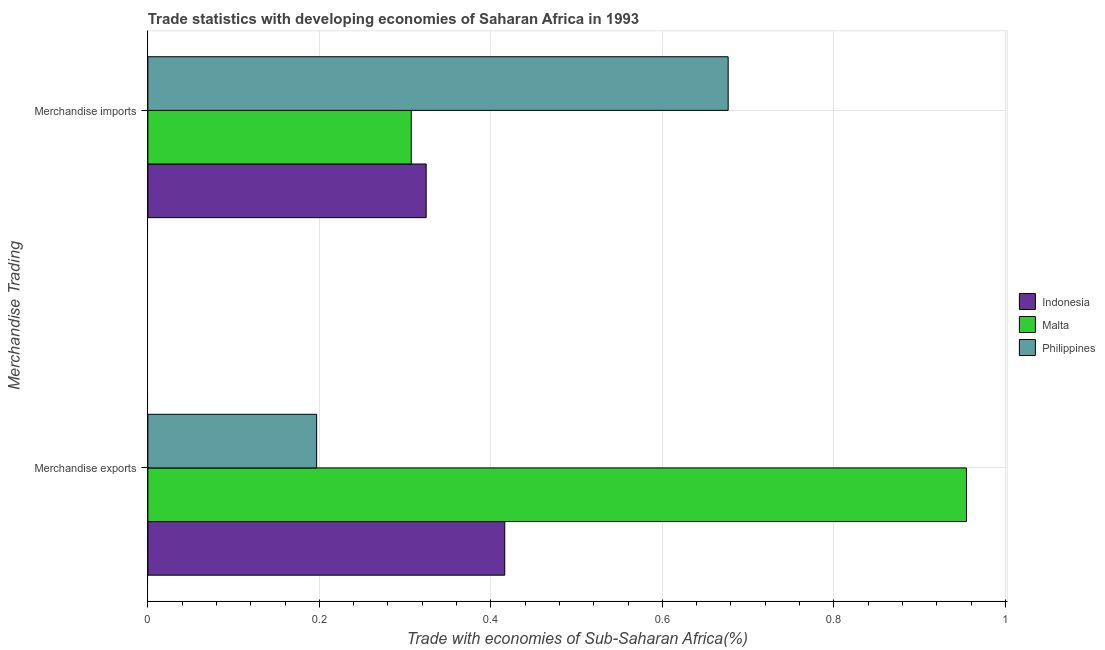How many different coloured bars are there?
Your answer should be compact. 3. How many bars are there on the 2nd tick from the bottom?
Keep it short and to the point. 3. What is the merchandise exports in Indonesia?
Make the answer very short. 0.42. Across all countries, what is the maximum merchandise imports?
Offer a very short reply. 0.68. Across all countries, what is the minimum merchandise exports?
Provide a short and direct response. 0.2. What is the total merchandise imports in the graph?
Keep it short and to the point. 1.31. What is the difference between the merchandise exports in Indonesia and that in Malta?
Provide a succinct answer. -0.54. What is the difference between the merchandise exports in Philippines and the merchandise imports in Malta?
Give a very brief answer. -0.11. What is the average merchandise imports per country?
Offer a terse response. 0.44. What is the difference between the merchandise exports and merchandise imports in Philippines?
Your answer should be compact. -0.48. In how many countries, is the merchandise imports greater than 0.04 %?
Ensure brevity in your answer.  3. What is the ratio of the merchandise imports in Philippines to that in Malta?
Your response must be concise. 2.2. Is the merchandise exports in Indonesia less than that in Philippines?
Give a very brief answer. No. In how many countries, is the merchandise exports greater than the average merchandise exports taken over all countries?
Ensure brevity in your answer.  1. How many bars are there?
Provide a succinct answer. 6. What is the difference between two consecutive major ticks on the X-axis?
Offer a very short reply. 0.2. Does the graph contain any zero values?
Keep it short and to the point. No. Does the graph contain grids?
Your response must be concise. Yes. Where does the legend appear in the graph?
Your response must be concise. Center right. How many legend labels are there?
Your answer should be compact. 3. How are the legend labels stacked?
Offer a very short reply. Vertical. What is the title of the graph?
Your response must be concise. Trade statistics with developing economies of Saharan Africa in 1993. Does "Liberia" appear as one of the legend labels in the graph?
Keep it short and to the point. No. What is the label or title of the X-axis?
Offer a terse response. Trade with economies of Sub-Saharan Africa(%). What is the label or title of the Y-axis?
Make the answer very short. Merchandise Trading. What is the Trade with economies of Sub-Saharan Africa(%) of Indonesia in Merchandise exports?
Your answer should be very brief. 0.42. What is the Trade with economies of Sub-Saharan Africa(%) of Malta in Merchandise exports?
Your response must be concise. 0.95. What is the Trade with economies of Sub-Saharan Africa(%) of Philippines in Merchandise exports?
Your answer should be compact. 0.2. What is the Trade with economies of Sub-Saharan Africa(%) in Indonesia in Merchandise imports?
Provide a succinct answer. 0.32. What is the Trade with economies of Sub-Saharan Africa(%) in Malta in Merchandise imports?
Offer a very short reply. 0.31. What is the Trade with economies of Sub-Saharan Africa(%) in Philippines in Merchandise imports?
Provide a succinct answer. 0.68. Across all Merchandise Trading, what is the maximum Trade with economies of Sub-Saharan Africa(%) in Indonesia?
Your answer should be very brief. 0.42. Across all Merchandise Trading, what is the maximum Trade with economies of Sub-Saharan Africa(%) in Malta?
Give a very brief answer. 0.95. Across all Merchandise Trading, what is the maximum Trade with economies of Sub-Saharan Africa(%) in Philippines?
Keep it short and to the point. 0.68. Across all Merchandise Trading, what is the minimum Trade with economies of Sub-Saharan Africa(%) of Indonesia?
Offer a very short reply. 0.32. Across all Merchandise Trading, what is the minimum Trade with economies of Sub-Saharan Africa(%) of Malta?
Ensure brevity in your answer.  0.31. Across all Merchandise Trading, what is the minimum Trade with economies of Sub-Saharan Africa(%) of Philippines?
Your answer should be very brief. 0.2. What is the total Trade with economies of Sub-Saharan Africa(%) in Indonesia in the graph?
Your answer should be very brief. 0.74. What is the total Trade with economies of Sub-Saharan Africa(%) in Malta in the graph?
Keep it short and to the point. 1.26. What is the total Trade with economies of Sub-Saharan Africa(%) of Philippines in the graph?
Ensure brevity in your answer.  0.87. What is the difference between the Trade with economies of Sub-Saharan Africa(%) of Indonesia in Merchandise exports and that in Merchandise imports?
Provide a short and direct response. 0.09. What is the difference between the Trade with economies of Sub-Saharan Africa(%) in Malta in Merchandise exports and that in Merchandise imports?
Provide a succinct answer. 0.65. What is the difference between the Trade with economies of Sub-Saharan Africa(%) of Philippines in Merchandise exports and that in Merchandise imports?
Give a very brief answer. -0.48. What is the difference between the Trade with economies of Sub-Saharan Africa(%) in Indonesia in Merchandise exports and the Trade with economies of Sub-Saharan Africa(%) in Malta in Merchandise imports?
Provide a succinct answer. 0.11. What is the difference between the Trade with economies of Sub-Saharan Africa(%) of Indonesia in Merchandise exports and the Trade with economies of Sub-Saharan Africa(%) of Philippines in Merchandise imports?
Your answer should be very brief. -0.26. What is the difference between the Trade with economies of Sub-Saharan Africa(%) of Malta in Merchandise exports and the Trade with economies of Sub-Saharan Africa(%) of Philippines in Merchandise imports?
Your response must be concise. 0.28. What is the average Trade with economies of Sub-Saharan Africa(%) in Indonesia per Merchandise Trading?
Provide a short and direct response. 0.37. What is the average Trade with economies of Sub-Saharan Africa(%) of Malta per Merchandise Trading?
Provide a succinct answer. 0.63. What is the average Trade with economies of Sub-Saharan Africa(%) of Philippines per Merchandise Trading?
Offer a very short reply. 0.44. What is the difference between the Trade with economies of Sub-Saharan Africa(%) of Indonesia and Trade with economies of Sub-Saharan Africa(%) of Malta in Merchandise exports?
Your answer should be compact. -0.54. What is the difference between the Trade with economies of Sub-Saharan Africa(%) of Indonesia and Trade with economies of Sub-Saharan Africa(%) of Philippines in Merchandise exports?
Offer a very short reply. 0.22. What is the difference between the Trade with economies of Sub-Saharan Africa(%) in Malta and Trade with economies of Sub-Saharan Africa(%) in Philippines in Merchandise exports?
Provide a short and direct response. 0.76. What is the difference between the Trade with economies of Sub-Saharan Africa(%) of Indonesia and Trade with economies of Sub-Saharan Africa(%) of Malta in Merchandise imports?
Your answer should be compact. 0.02. What is the difference between the Trade with economies of Sub-Saharan Africa(%) of Indonesia and Trade with economies of Sub-Saharan Africa(%) of Philippines in Merchandise imports?
Ensure brevity in your answer.  -0.35. What is the difference between the Trade with economies of Sub-Saharan Africa(%) of Malta and Trade with economies of Sub-Saharan Africa(%) of Philippines in Merchandise imports?
Keep it short and to the point. -0.37. What is the ratio of the Trade with economies of Sub-Saharan Africa(%) in Indonesia in Merchandise exports to that in Merchandise imports?
Make the answer very short. 1.28. What is the ratio of the Trade with economies of Sub-Saharan Africa(%) of Malta in Merchandise exports to that in Merchandise imports?
Give a very brief answer. 3.11. What is the ratio of the Trade with economies of Sub-Saharan Africa(%) of Philippines in Merchandise exports to that in Merchandise imports?
Your answer should be very brief. 0.29. What is the difference between the highest and the second highest Trade with economies of Sub-Saharan Africa(%) in Indonesia?
Your answer should be very brief. 0.09. What is the difference between the highest and the second highest Trade with economies of Sub-Saharan Africa(%) of Malta?
Make the answer very short. 0.65. What is the difference between the highest and the second highest Trade with economies of Sub-Saharan Africa(%) in Philippines?
Your answer should be very brief. 0.48. What is the difference between the highest and the lowest Trade with economies of Sub-Saharan Africa(%) in Indonesia?
Give a very brief answer. 0.09. What is the difference between the highest and the lowest Trade with economies of Sub-Saharan Africa(%) of Malta?
Your answer should be very brief. 0.65. What is the difference between the highest and the lowest Trade with economies of Sub-Saharan Africa(%) of Philippines?
Keep it short and to the point. 0.48. 